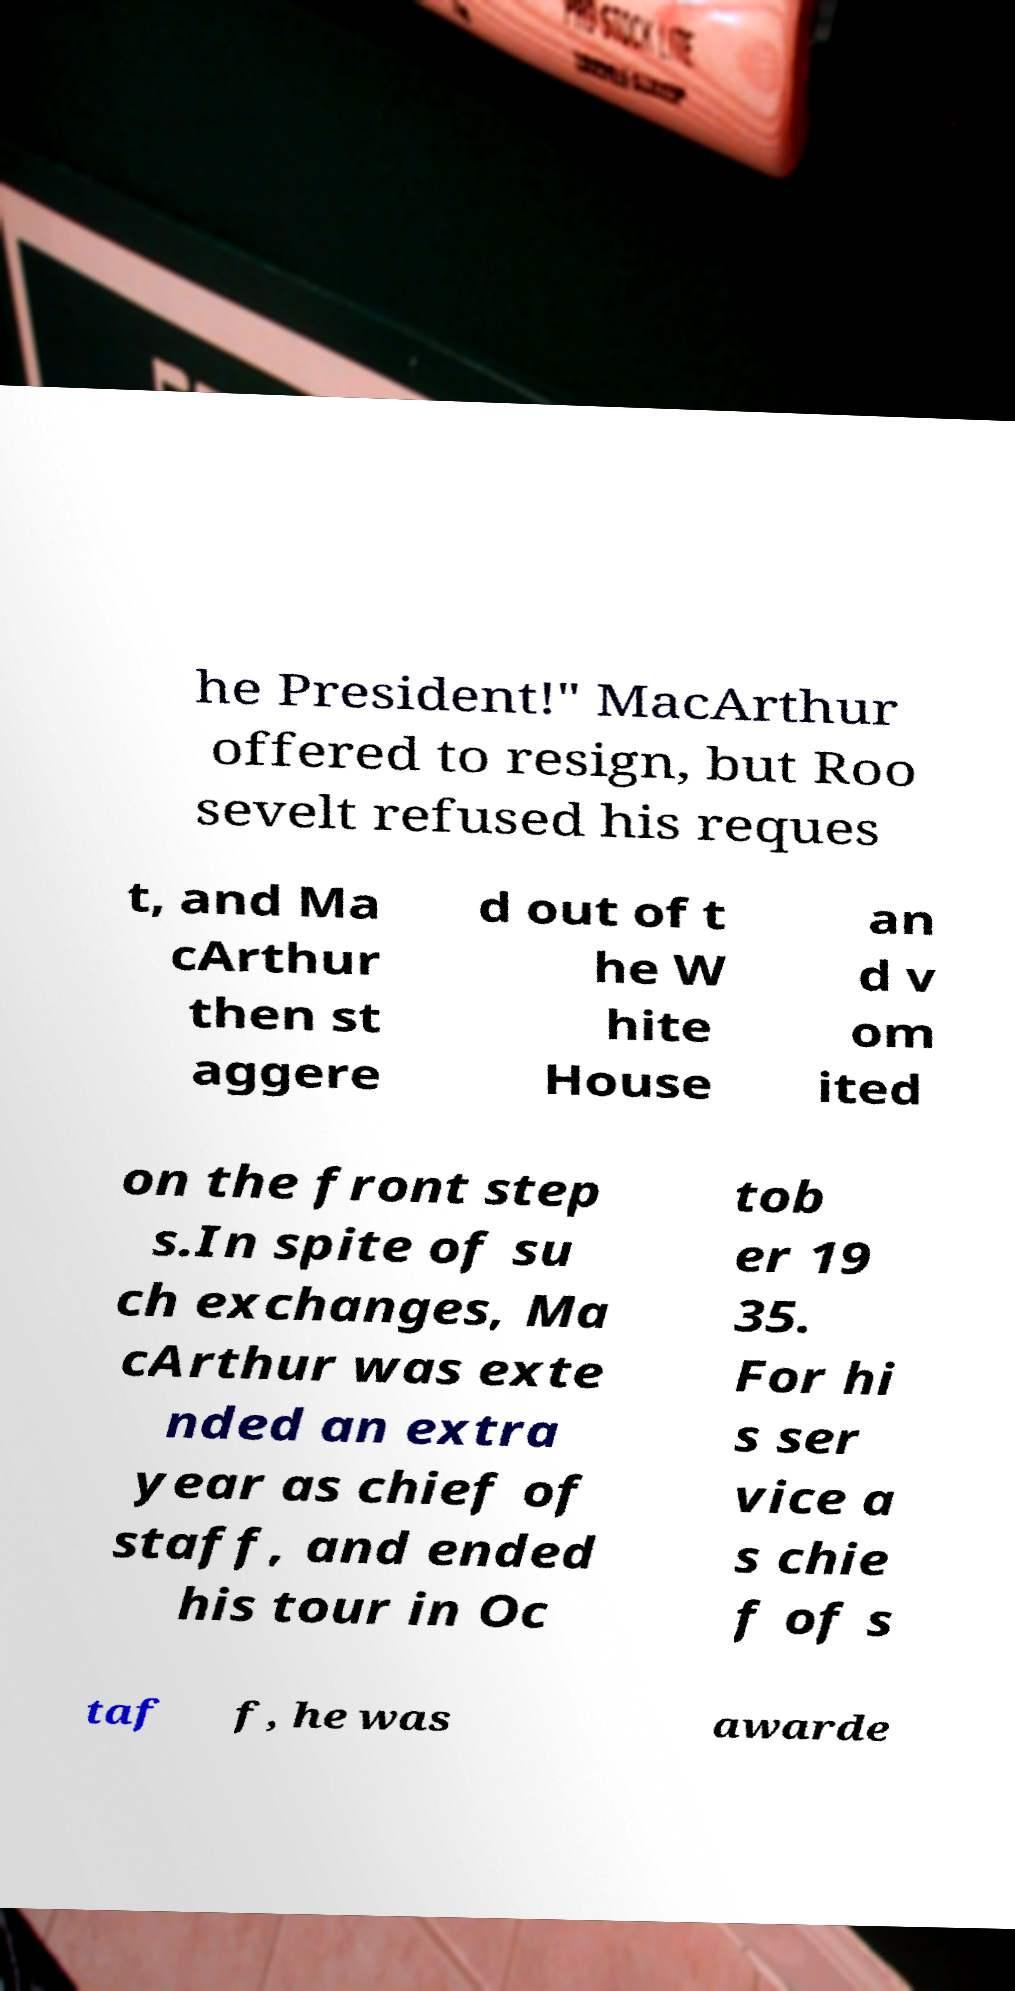What messages or text are displayed in this image? I need them in a readable, typed format. he President!" MacArthur offered to resign, but Roo sevelt refused his reques t, and Ma cArthur then st aggere d out of t he W hite House an d v om ited on the front step s.In spite of su ch exchanges, Ma cArthur was exte nded an extra year as chief of staff, and ended his tour in Oc tob er 19 35. For hi s ser vice a s chie f of s taf f, he was awarde 